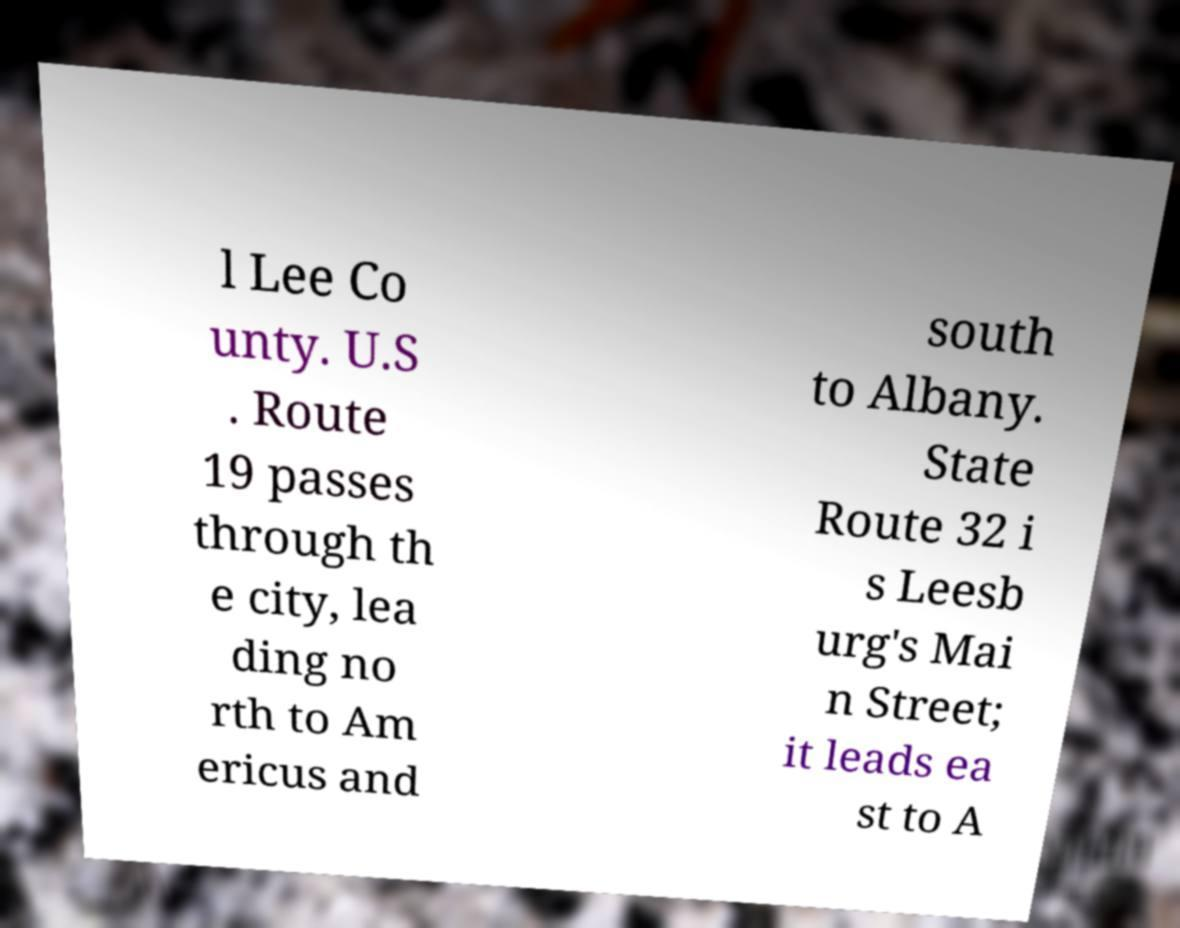Could you extract and type out the text from this image? l Lee Co unty. U.S . Route 19 passes through th e city, lea ding no rth to Am ericus and south to Albany. State Route 32 i s Leesb urg's Mai n Street; it leads ea st to A 